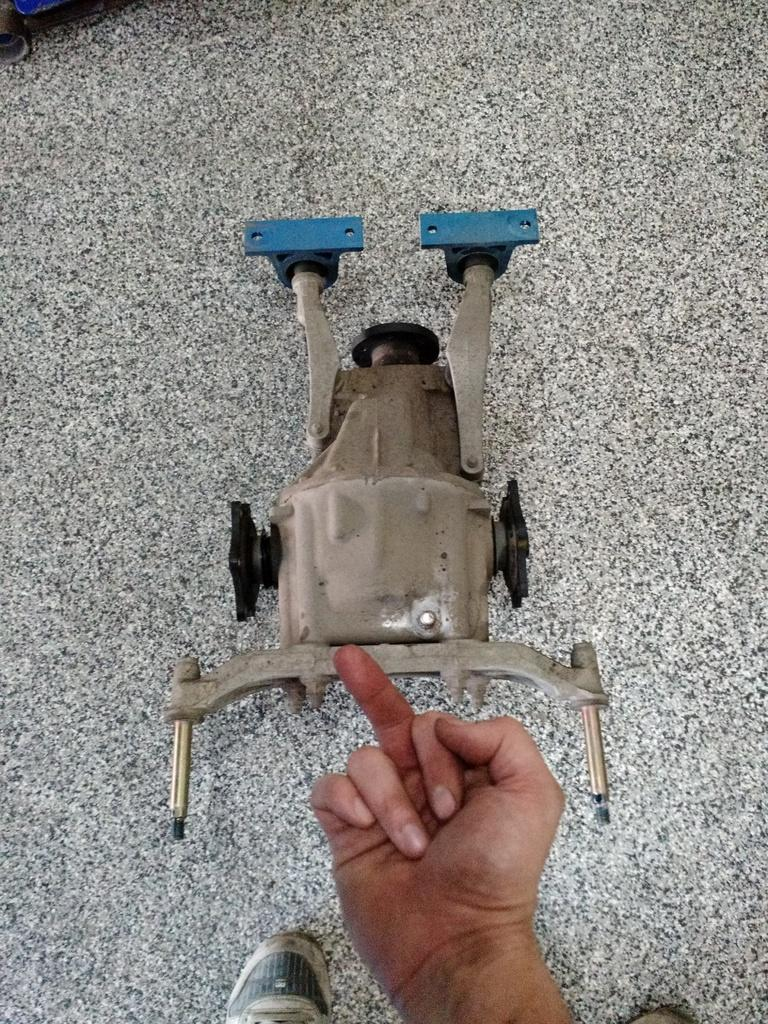What is located on the floor in the image? There is an object on the floor in the image. Can you describe the person in the image? There is a person standing in front of the object, but only their hand and legs are visible. What type of sock is the person pulling in the image? There is no sock present in the image, and the person is not pulling anything. How does the person perform magic in the image? There is no magic or indication of magic in the image. 